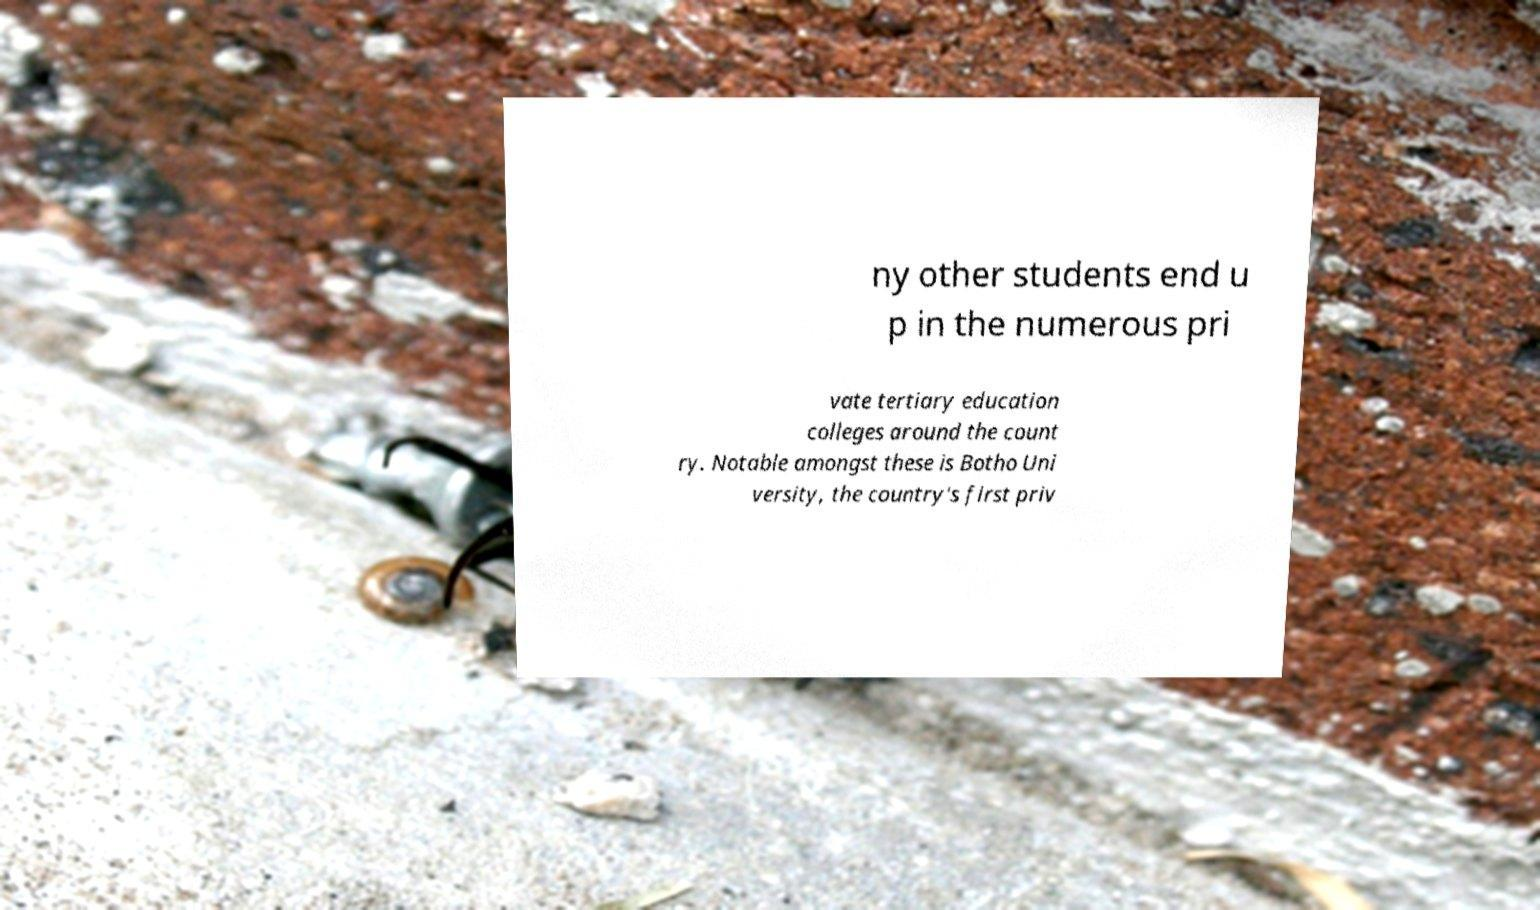Could you extract and type out the text from this image? ny other students end u p in the numerous pri vate tertiary education colleges around the count ry. Notable amongst these is Botho Uni versity, the country's first priv 